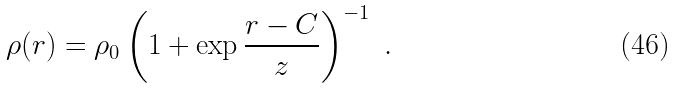Convert formula to latex. <formula><loc_0><loc_0><loc_500><loc_500>\rho ( r ) = \rho _ { 0 } \left ( 1 + \exp \frac { r - C } { z } \right ) ^ { - 1 } \ .</formula> 